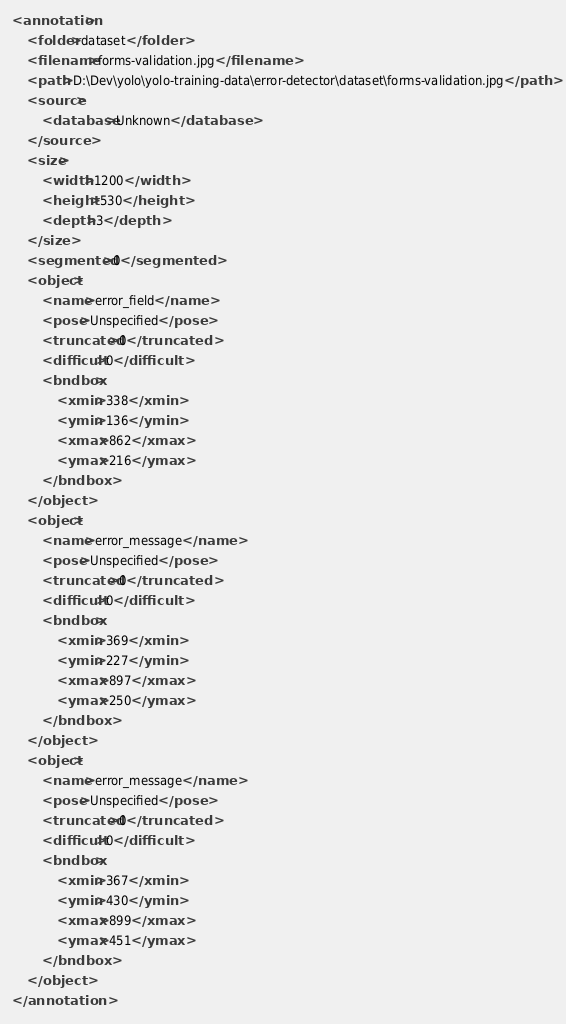Convert code to text. <code><loc_0><loc_0><loc_500><loc_500><_XML_><annotation>
	<folder>dataset</folder>
	<filename>forms-validation.jpg</filename>
	<path>D:\Dev\yolo\yolo-training-data\error-detector\dataset\forms-validation.jpg</path>
	<source>
		<database>Unknown</database>
	</source>
	<size>
		<width>1200</width>
		<height>530</height>
		<depth>3</depth>
	</size>
	<segmented>0</segmented>
	<object>
		<name>error_field</name>
		<pose>Unspecified</pose>
		<truncated>0</truncated>
		<difficult>0</difficult>
		<bndbox>
			<xmin>338</xmin>
			<ymin>136</ymin>
			<xmax>862</xmax>
			<ymax>216</ymax>
		</bndbox>
	</object>
	<object>
		<name>error_message</name>
		<pose>Unspecified</pose>
		<truncated>0</truncated>
		<difficult>0</difficult>
		<bndbox>
			<xmin>369</xmin>
			<ymin>227</ymin>
			<xmax>897</xmax>
			<ymax>250</ymax>
		</bndbox>
	</object>
	<object>
		<name>error_message</name>
		<pose>Unspecified</pose>
		<truncated>0</truncated>
		<difficult>0</difficult>
		<bndbox>
			<xmin>367</xmin>
			<ymin>430</ymin>
			<xmax>899</xmax>
			<ymax>451</ymax>
		</bndbox>
	</object>
</annotation>
</code> 